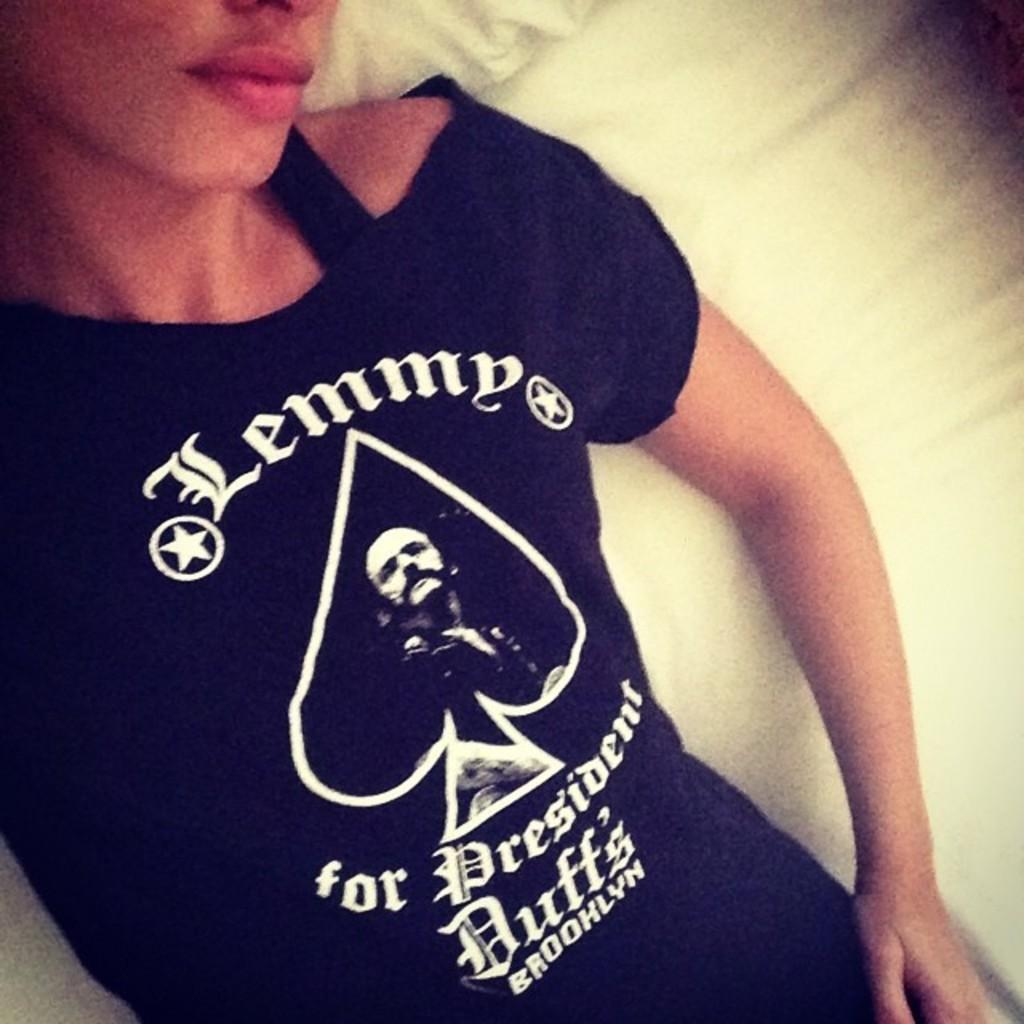What is the main subject of the image? There is a person in the image. What is the person doing in the image? The person is lying on a bed. What type of plate can be seen on the person's head in the image? There is no plate present on the person's head in the image. Can you spot any ants crawling on the bed in the image? There is no mention of ants in the image, so it cannot be determined if any are present. Is there a cactus visible in the image? There is no mention of a cactus in the image, so it cannot be determined if one is present. 